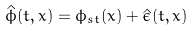Convert formula to latex. <formula><loc_0><loc_0><loc_500><loc_500>\hat { \phi } ( t , x ) = \phi _ { s t } ( x ) + \hat { \epsilon } ( t , x )</formula> 